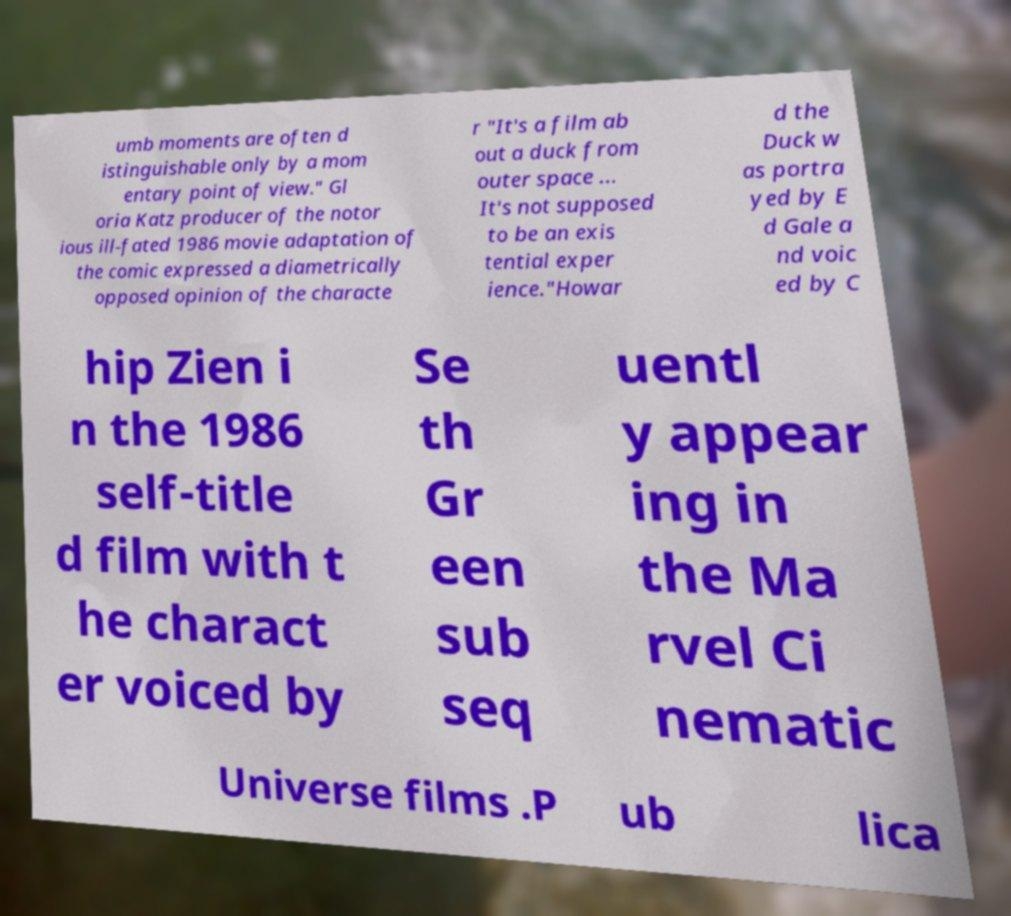Can you read and provide the text displayed in the image?This photo seems to have some interesting text. Can you extract and type it out for me? umb moments are often d istinguishable only by a mom entary point of view." Gl oria Katz producer of the notor ious ill-fated 1986 movie adaptation of the comic expressed a diametrically opposed opinion of the characte r "It's a film ab out a duck from outer space ... It's not supposed to be an exis tential exper ience."Howar d the Duck w as portra yed by E d Gale a nd voic ed by C hip Zien i n the 1986 self-title d film with t he charact er voiced by Se th Gr een sub seq uentl y appear ing in the Ma rvel Ci nematic Universe films .P ub lica 